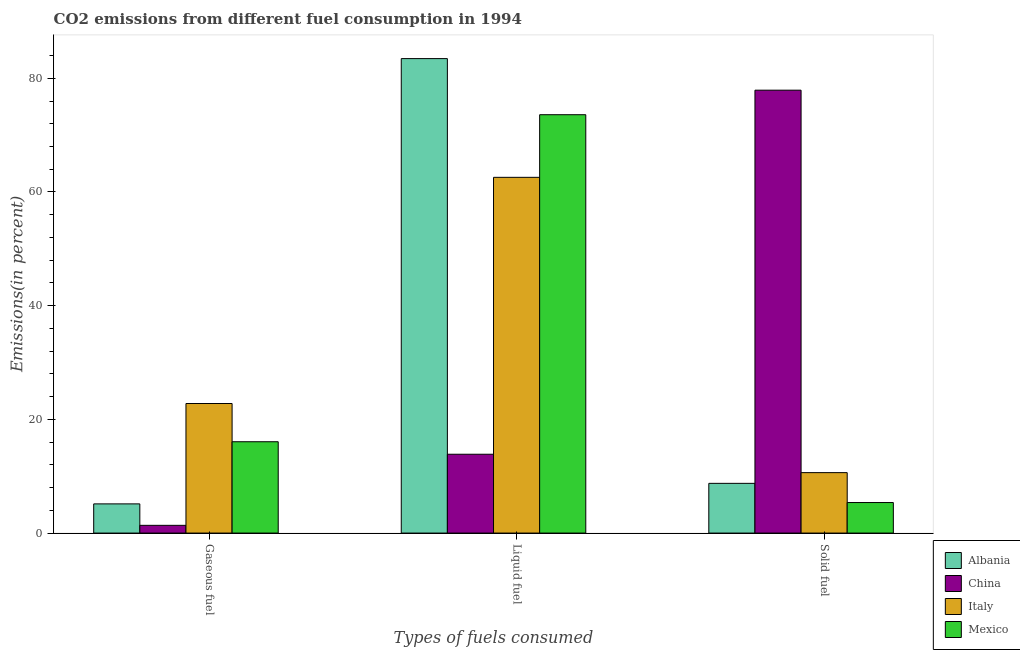How many different coloured bars are there?
Offer a very short reply. 4. Are the number of bars per tick equal to the number of legend labels?
Provide a short and direct response. Yes. Are the number of bars on each tick of the X-axis equal?
Keep it short and to the point. Yes. What is the label of the 3rd group of bars from the left?
Ensure brevity in your answer.  Solid fuel. What is the percentage of liquid fuel emission in China?
Your answer should be very brief. 13.87. Across all countries, what is the maximum percentage of solid fuel emission?
Your answer should be compact. 77.91. Across all countries, what is the minimum percentage of gaseous fuel emission?
Offer a terse response. 1.36. In which country was the percentage of gaseous fuel emission maximum?
Your answer should be compact. Italy. What is the total percentage of solid fuel emission in the graph?
Provide a succinct answer. 102.65. What is the difference between the percentage of gaseous fuel emission in Italy and that in Mexico?
Keep it short and to the point. 6.72. What is the difference between the percentage of liquid fuel emission in Albania and the percentage of solid fuel emission in Italy?
Provide a succinct answer. 72.83. What is the average percentage of gaseous fuel emission per country?
Offer a terse response. 11.34. What is the difference between the percentage of liquid fuel emission and percentage of solid fuel emission in Italy?
Your response must be concise. 51.94. What is the ratio of the percentage of gaseous fuel emission in China to that in Albania?
Provide a succinct answer. 0.27. Is the percentage of gaseous fuel emission in Albania less than that in China?
Provide a short and direct response. No. What is the difference between the highest and the second highest percentage of solid fuel emission?
Provide a short and direct response. 67.27. What is the difference between the highest and the lowest percentage of solid fuel emission?
Your response must be concise. 72.53. In how many countries, is the percentage of gaseous fuel emission greater than the average percentage of gaseous fuel emission taken over all countries?
Provide a short and direct response. 2. Are all the bars in the graph horizontal?
Your answer should be compact. No. Are the values on the major ticks of Y-axis written in scientific E-notation?
Your response must be concise. No. Does the graph contain any zero values?
Give a very brief answer. No. Where does the legend appear in the graph?
Keep it short and to the point. Bottom right. How many legend labels are there?
Offer a terse response. 4. What is the title of the graph?
Offer a very short reply. CO2 emissions from different fuel consumption in 1994. What is the label or title of the X-axis?
Offer a very short reply. Types of fuels consumed. What is the label or title of the Y-axis?
Offer a terse response. Emissions(in percent). What is the Emissions(in percent) in Albania in Gaseous fuel?
Your response must be concise. 5.13. What is the Emissions(in percent) in China in Gaseous fuel?
Your answer should be very brief. 1.36. What is the Emissions(in percent) of Italy in Gaseous fuel?
Give a very brief answer. 22.79. What is the Emissions(in percent) in Mexico in Gaseous fuel?
Your answer should be compact. 16.07. What is the Emissions(in percent) in Albania in Liquid fuel?
Your response must be concise. 83.46. What is the Emissions(in percent) in China in Liquid fuel?
Your response must be concise. 13.87. What is the Emissions(in percent) of Italy in Liquid fuel?
Your response must be concise. 62.57. What is the Emissions(in percent) of Mexico in Liquid fuel?
Keep it short and to the point. 73.59. What is the Emissions(in percent) of Albania in Solid fuel?
Keep it short and to the point. 8.75. What is the Emissions(in percent) of China in Solid fuel?
Ensure brevity in your answer.  77.91. What is the Emissions(in percent) in Italy in Solid fuel?
Your answer should be very brief. 10.63. What is the Emissions(in percent) of Mexico in Solid fuel?
Ensure brevity in your answer.  5.37. Across all Types of fuels consumed, what is the maximum Emissions(in percent) of Albania?
Keep it short and to the point. 83.46. Across all Types of fuels consumed, what is the maximum Emissions(in percent) in China?
Offer a terse response. 77.91. Across all Types of fuels consumed, what is the maximum Emissions(in percent) of Italy?
Your answer should be very brief. 62.57. Across all Types of fuels consumed, what is the maximum Emissions(in percent) of Mexico?
Offer a terse response. 73.59. Across all Types of fuels consumed, what is the minimum Emissions(in percent) of Albania?
Your response must be concise. 5.13. Across all Types of fuels consumed, what is the minimum Emissions(in percent) in China?
Make the answer very short. 1.36. Across all Types of fuels consumed, what is the minimum Emissions(in percent) in Italy?
Provide a short and direct response. 10.63. Across all Types of fuels consumed, what is the minimum Emissions(in percent) in Mexico?
Provide a short and direct response. 5.37. What is the total Emissions(in percent) in Albania in the graph?
Your answer should be very brief. 97.34. What is the total Emissions(in percent) of China in the graph?
Offer a very short reply. 93.13. What is the total Emissions(in percent) of Italy in the graph?
Make the answer very short. 96. What is the total Emissions(in percent) in Mexico in the graph?
Keep it short and to the point. 95.03. What is the difference between the Emissions(in percent) in Albania in Gaseous fuel and that in Liquid fuel?
Your response must be concise. -78.33. What is the difference between the Emissions(in percent) of China in Gaseous fuel and that in Liquid fuel?
Keep it short and to the point. -12.51. What is the difference between the Emissions(in percent) in Italy in Gaseous fuel and that in Liquid fuel?
Offer a very short reply. -39.78. What is the difference between the Emissions(in percent) in Mexico in Gaseous fuel and that in Liquid fuel?
Give a very brief answer. -57.53. What is the difference between the Emissions(in percent) of Albania in Gaseous fuel and that in Solid fuel?
Offer a very short reply. -3.61. What is the difference between the Emissions(in percent) of China in Gaseous fuel and that in Solid fuel?
Your response must be concise. -76.55. What is the difference between the Emissions(in percent) in Italy in Gaseous fuel and that in Solid fuel?
Provide a succinct answer. 12.16. What is the difference between the Emissions(in percent) in Mexico in Gaseous fuel and that in Solid fuel?
Provide a short and direct response. 10.69. What is the difference between the Emissions(in percent) in Albania in Liquid fuel and that in Solid fuel?
Keep it short and to the point. 74.71. What is the difference between the Emissions(in percent) in China in Liquid fuel and that in Solid fuel?
Your answer should be very brief. -64.04. What is the difference between the Emissions(in percent) of Italy in Liquid fuel and that in Solid fuel?
Ensure brevity in your answer.  51.94. What is the difference between the Emissions(in percent) of Mexico in Liquid fuel and that in Solid fuel?
Give a very brief answer. 68.22. What is the difference between the Emissions(in percent) of Albania in Gaseous fuel and the Emissions(in percent) of China in Liquid fuel?
Offer a very short reply. -8.73. What is the difference between the Emissions(in percent) of Albania in Gaseous fuel and the Emissions(in percent) of Italy in Liquid fuel?
Offer a very short reply. -57.44. What is the difference between the Emissions(in percent) of Albania in Gaseous fuel and the Emissions(in percent) of Mexico in Liquid fuel?
Your answer should be very brief. -68.46. What is the difference between the Emissions(in percent) in China in Gaseous fuel and the Emissions(in percent) in Italy in Liquid fuel?
Make the answer very short. -61.21. What is the difference between the Emissions(in percent) of China in Gaseous fuel and the Emissions(in percent) of Mexico in Liquid fuel?
Offer a very short reply. -72.23. What is the difference between the Emissions(in percent) of Italy in Gaseous fuel and the Emissions(in percent) of Mexico in Liquid fuel?
Ensure brevity in your answer.  -50.8. What is the difference between the Emissions(in percent) of Albania in Gaseous fuel and the Emissions(in percent) of China in Solid fuel?
Keep it short and to the point. -72.77. What is the difference between the Emissions(in percent) of Albania in Gaseous fuel and the Emissions(in percent) of Italy in Solid fuel?
Your answer should be compact. -5.5. What is the difference between the Emissions(in percent) of Albania in Gaseous fuel and the Emissions(in percent) of Mexico in Solid fuel?
Your answer should be very brief. -0.24. What is the difference between the Emissions(in percent) in China in Gaseous fuel and the Emissions(in percent) in Italy in Solid fuel?
Make the answer very short. -9.27. What is the difference between the Emissions(in percent) of China in Gaseous fuel and the Emissions(in percent) of Mexico in Solid fuel?
Provide a short and direct response. -4.01. What is the difference between the Emissions(in percent) of Italy in Gaseous fuel and the Emissions(in percent) of Mexico in Solid fuel?
Your answer should be compact. 17.42. What is the difference between the Emissions(in percent) in Albania in Liquid fuel and the Emissions(in percent) in China in Solid fuel?
Your response must be concise. 5.55. What is the difference between the Emissions(in percent) of Albania in Liquid fuel and the Emissions(in percent) of Italy in Solid fuel?
Give a very brief answer. 72.83. What is the difference between the Emissions(in percent) of Albania in Liquid fuel and the Emissions(in percent) of Mexico in Solid fuel?
Your response must be concise. 78.09. What is the difference between the Emissions(in percent) of China in Liquid fuel and the Emissions(in percent) of Italy in Solid fuel?
Ensure brevity in your answer.  3.23. What is the difference between the Emissions(in percent) of China in Liquid fuel and the Emissions(in percent) of Mexico in Solid fuel?
Make the answer very short. 8.5. What is the difference between the Emissions(in percent) in Italy in Liquid fuel and the Emissions(in percent) in Mexico in Solid fuel?
Your response must be concise. 57.2. What is the average Emissions(in percent) in Albania per Types of fuels consumed?
Offer a very short reply. 32.45. What is the average Emissions(in percent) in China per Types of fuels consumed?
Offer a terse response. 31.04. What is the average Emissions(in percent) in Italy per Types of fuels consumed?
Ensure brevity in your answer.  32. What is the average Emissions(in percent) in Mexico per Types of fuels consumed?
Your answer should be very brief. 31.68. What is the difference between the Emissions(in percent) of Albania and Emissions(in percent) of China in Gaseous fuel?
Offer a very short reply. 3.77. What is the difference between the Emissions(in percent) in Albania and Emissions(in percent) in Italy in Gaseous fuel?
Give a very brief answer. -17.66. What is the difference between the Emissions(in percent) of Albania and Emissions(in percent) of Mexico in Gaseous fuel?
Ensure brevity in your answer.  -10.93. What is the difference between the Emissions(in percent) of China and Emissions(in percent) of Italy in Gaseous fuel?
Your response must be concise. -21.43. What is the difference between the Emissions(in percent) of China and Emissions(in percent) of Mexico in Gaseous fuel?
Ensure brevity in your answer.  -14.71. What is the difference between the Emissions(in percent) of Italy and Emissions(in percent) of Mexico in Gaseous fuel?
Provide a short and direct response. 6.72. What is the difference between the Emissions(in percent) in Albania and Emissions(in percent) in China in Liquid fuel?
Ensure brevity in your answer.  69.59. What is the difference between the Emissions(in percent) of Albania and Emissions(in percent) of Italy in Liquid fuel?
Your response must be concise. 20.89. What is the difference between the Emissions(in percent) of Albania and Emissions(in percent) of Mexico in Liquid fuel?
Offer a very short reply. 9.87. What is the difference between the Emissions(in percent) of China and Emissions(in percent) of Italy in Liquid fuel?
Your answer should be compact. -48.71. What is the difference between the Emissions(in percent) in China and Emissions(in percent) in Mexico in Liquid fuel?
Offer a terse response. -59.72. What is the difference between the Emissions(in percent) in Italy and Emissions(in percent) in Mexico in Liquid fuel?
Provide a short and direct response. -11.02. What is the difference between the Emissions(in percent) in Albania and Emissions(in percent) in China in Solid fuel?
Your answer should be compact. -69.16. What is the difference between the Emissions(in percent) of Albania and Emissions(in percent) of Italy in Solid fuel?
Ensure brevity in your answer.  -1.89. What is the difference between the Emissions(in percent) of Albania and Emissions(in percent) of Mexico in Solid fuel?
Your answer should be compact. 3.37. What is the difference between the Emissions(in percent) of China and Emissions(in percent) of Italy in Solid fuel?
Provide a short and direct response. 67.27. What is the difference between the Emissions(in percent) in China and Emissions(in percent) in Mexico in Solid fuel?
Offer a very short reply. 72.53. What is the difference between the Emissions(in percent) in Italy and Emissions(in percent) in Mexico in Solid fuel?
Make the answer very short. 5.26. What is the ratio of the Emissions(in percent) in Albania in Gaseous fuel to that in Liquid fuel?
Keep it short and to the point. 0.06. What is the ratio of the Emissions(in percent) of China in Gaseous fuel to that in Liquid fuel?
Your answer should be compact. 0.1. What is the ratio of the Emissions(in percent) in Italy in Gaseous fuel to that in Liquid fuel?
Make the answer very short. 0.36. What is the ratio of the Emissions(in percent) of Mexico in Gaseous fuel to that in Liquid fuel?
Offer a very short reply. 0.22. What is the ratio of the Emissions(in percent) of Albania in Gaseous fuel to that in Solid fuel?
Your answer should be compact. 0.59. What is the ratio of the Emissions(in percent) in China in Gaseous fuel to that in Solid fuel?
Your answer should be very brief. 0.02. What is the ratio of the Emissions(in percent) of Italy in Gaseous fuel to that in Solid fuel?
Your answer should be compact. 2.14. What is the ratio of the Emissions(in percent) in Mexico in Gaseous fuel to that in Solid fuel?
Your answer should be very brief. 2.99. What is the ratio of the Emissions(in percent) of Albania in Liquid fuel to that in Solid fuel?
Give a very brief answer. 9.54. What is the ratio of the Emissions(in percent) in China in Liquid fuel to that in Solid fuel?
Your answer should be compact. 0.18. What is the ratio of the Emissions(in percent) in Italy in Liquid fuel to that in Solid fuel?
Offer a very short reply. 5.89. What is the ratio of the Emissions(in percent) of Mexico in Liquid fuel to that in Solid fuel?
Offer a terse response. 13.7. What is the difference between the highest and the second highest Emissions(in percent) in Albania?
Your response must be concise. 74.71. What is the difference between the highest and the second highest Emissions(in percent) in China?
Your answer should be very brief. 64.04. What is the difference between the highest and the second highest Emissions(in percent) in Italy?
Give a very brief answer. 39.78. What is the difference between the highest and the second highest Emissions(in percent) of Mexico?
Offer a very short reply. 57.53. What is the difference between the highest and the lowest Emissions(in percent) of Albania?
Offer a terse response. 78.33. What is the difference between the highest and the lowest Emissions(in percent) of China?
Your answer should be compact. 76.55. What is the difference between the highest and the lowest Emissions(in percent) of Italy?
Your response must be concise. 51.94. What is the difference between the highest and the lowest Emissions(in percent) of Mexico?
Provide a succinct answer. 68.22. 